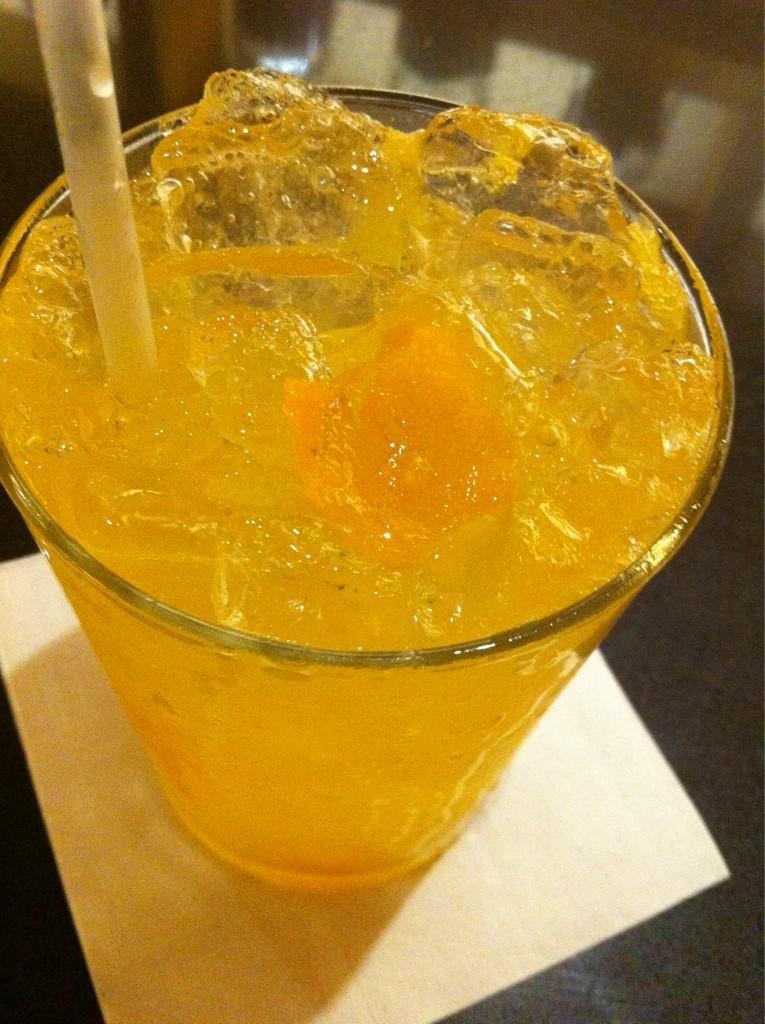Describe this image in one or two sentences. In this picture there is drink and there are ice cubes and there is straw in the glass. At the bottom it looks like a tissue on the table. 